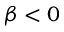<formula> <loc_0><loc_0><loc_500><loc_500>\beta < 0</formula> 